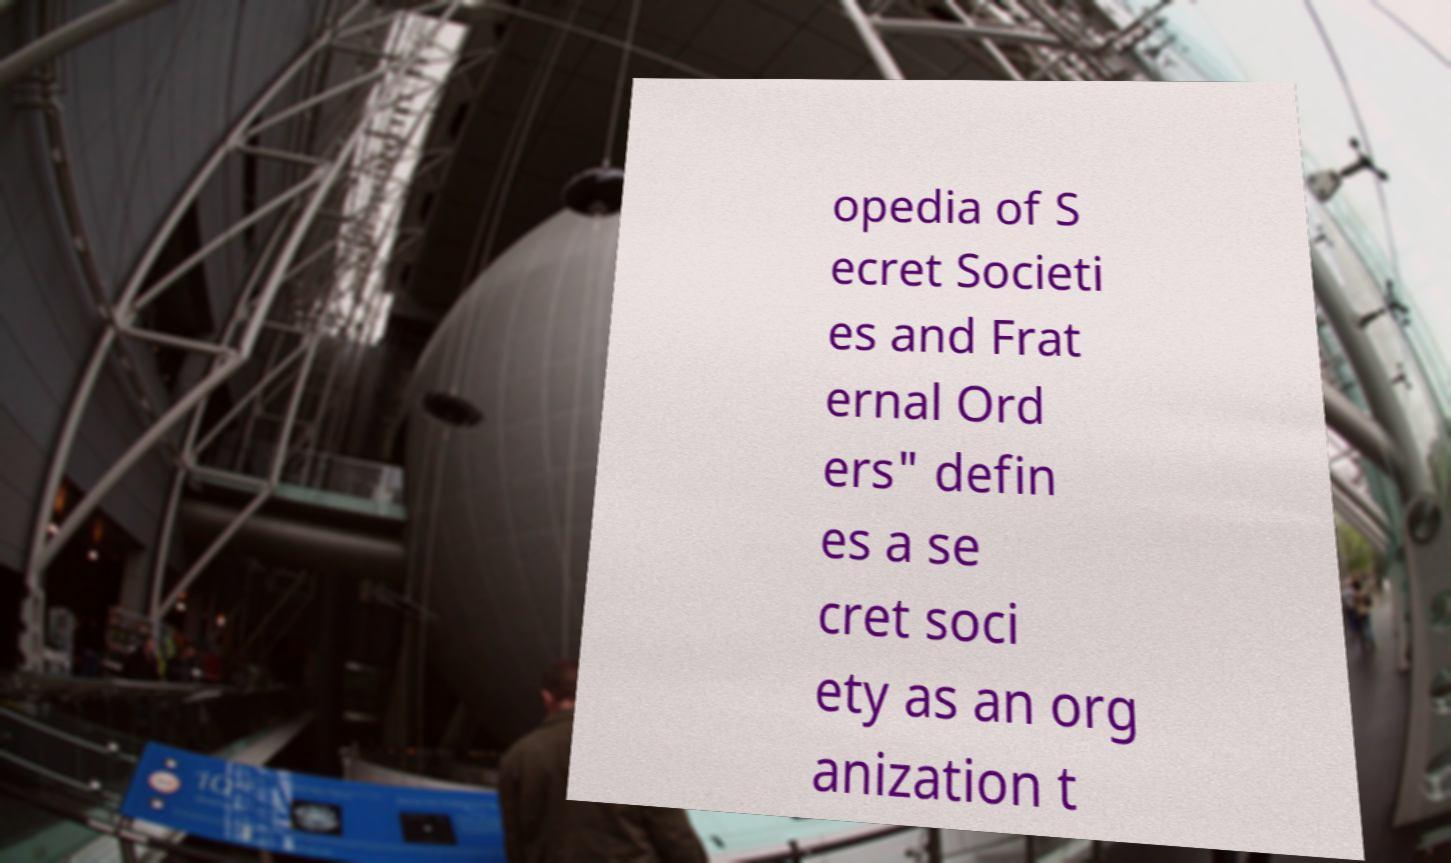Could you extract and type out the text from this image? opedia of S ecret Societi es and Frat ernal Ord ers" defin es a se cret soci ety as an org anization t 